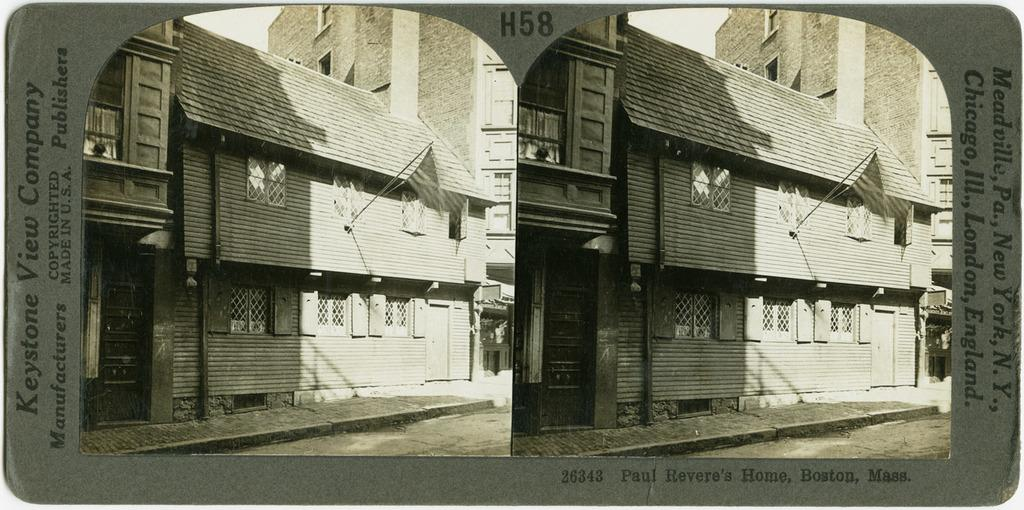What type of image is being described? The image is a collage photo. What can be seen in the collage photo? There are buildings in the image. Are there any words or phrases in the image? Yes, there is text in the image. When is the recess time for the children in the image? There are no children or indication of recess time in the image; it features a collage of buildings and text. What type of range is visible in the image? There is no range, such as a stove or a distance, present in the image; it consists of a collage of buildings and text. 